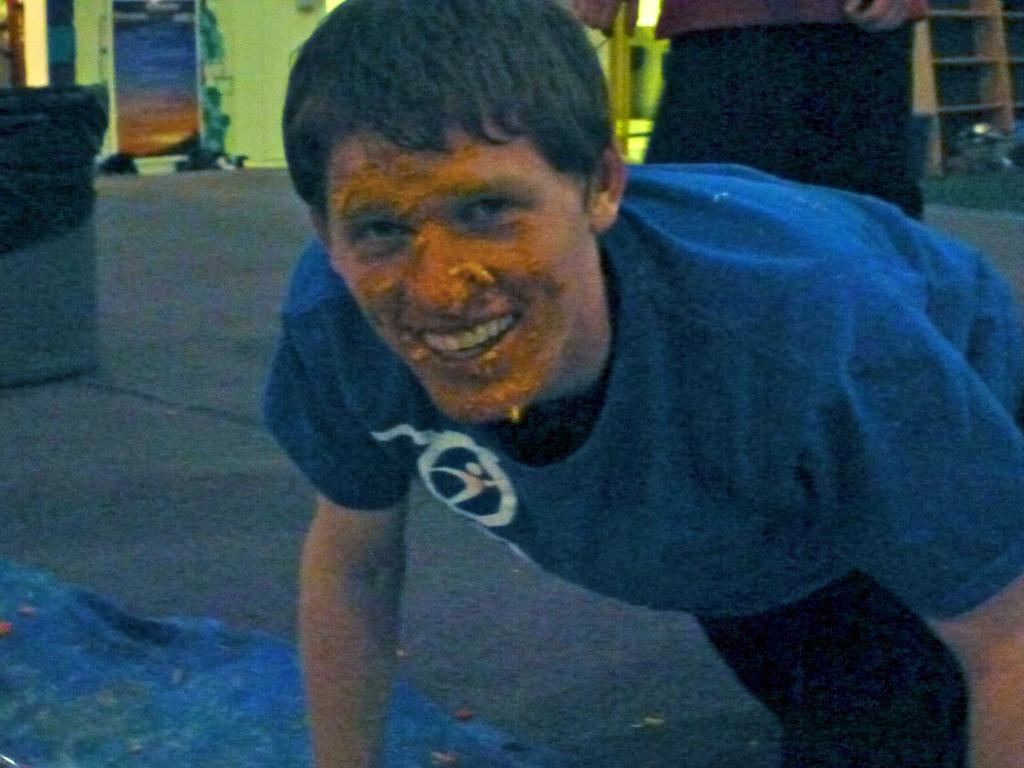What is the person in the image wearing? The person in the image is wearing a blue t-shirt. What can be seen on the person's face? There is something on the person's face. Can you describe the other person in the image? There is another person behind the person with the blue t-shirt. What is the plot of the story being told in the image? There is no story being told in the image, as it is a static photograph. 